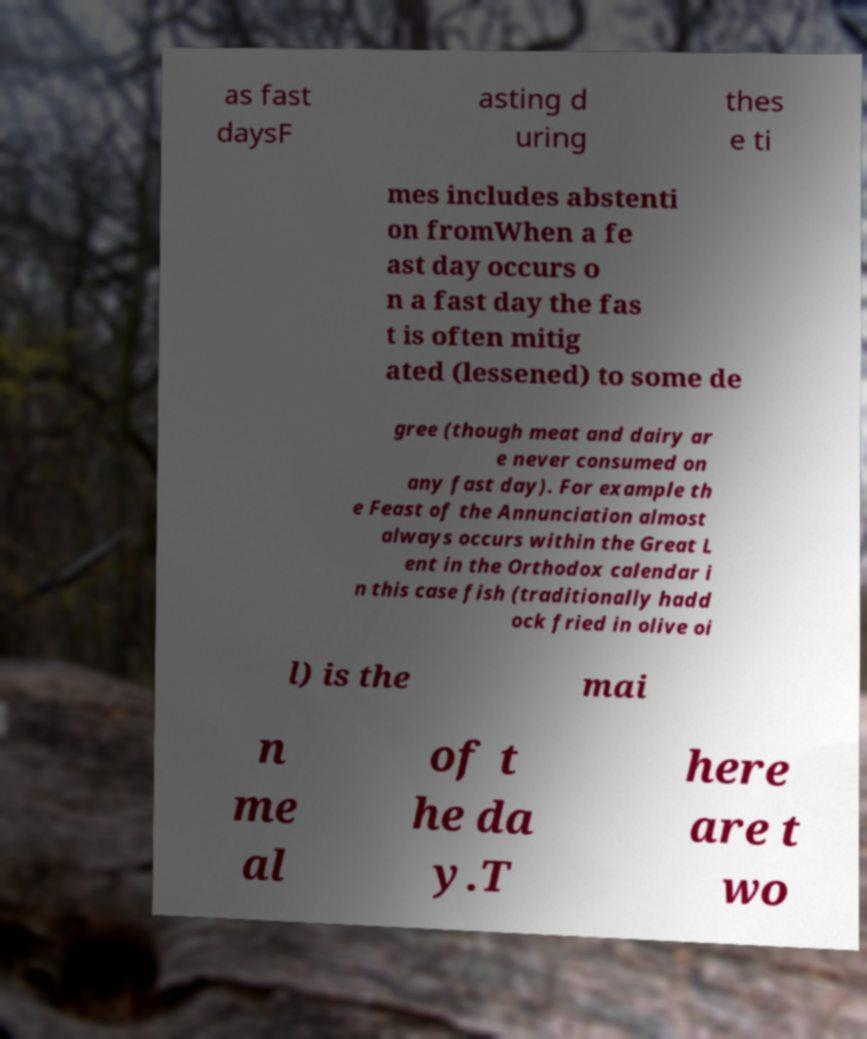Please identify and transcribe the text found in this image. as fast daysF asting d uring thes e ti mes includes abstenti on fromWhen a fe ast day occurs o n a fast day the fas t is often mitig ated (lessened) to some de gree (though meat and dairy ar e never consumed on any fast day). For example th e Feast of the Annunciation almost always occurs within the Great L ent in the Orthodox calendar i n this case fish (traditionally hadd ock fried in olive oi l) is the mai n me al of t he da y.T here are t wo 